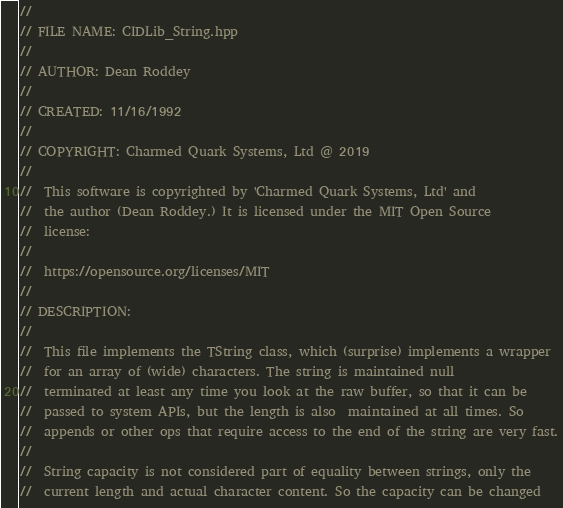Convert code to text. <code><loc_0><loc_0><loc_500><loc_500><_C++_>//
// FILE NAME: CIDLib_String.hpp
//
// AUTHOR: Dean Roddey
//
// CREATED: 11/16/1992
//
// COPYRIGHT: Charmed Quark Systems, Ltd @ 2019
//
//  This software is copyrighted by 'Charmed Quark Systems, Ltd' and
//  the author (Dean Roddey.) It is licensed under the MIT Open Source
//  license:
//
//  https://opensource.org/licenses/MIT
//
// DESCRIPTION:
//
//  This file implements the TString class, which (surprise) implements a wrapper
//  for an array of (wide) characters. The string is maintained null
//  terminated at least any time you look at the raw buffer, so that it can be
//  passed to system APIs, but the length is also  maintained at all times. So
//  appends or other ops that require access to the end of the string are very fast.
//
//  String capacity is not considered part of equality between strings, only the
//  current length and actual character content. So the capacity can be changed</code> 